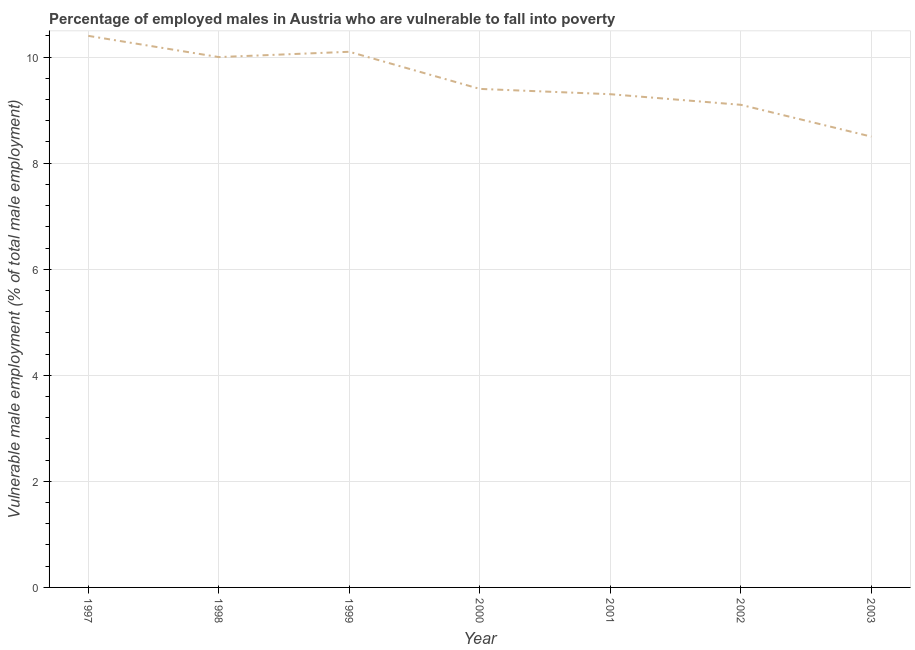What is the percentage of employed males who are vulnerable to fall into poverty in 2002?
Offer a terse response. 9.1. Across all years, what is the maximum percentage of employed males who are vulnerable to fall into poverty?
Ensure brevity in your answer.  10.4. In which year was the percentage of employed males who are vulnerable to fall into poverty minimum?
Give a very brief answer. 2003. What is the sum of the percentage of employed males who are vulnerable to fall into poverty?
Your response must be concise. 66.8. What is the difference between the percentage of employed males who are vulnerable to fall into poverty in 1997 and 2001?
Offer a terse response. 1.1. What is the average percentage of employed males who are vulnerable to fall into poverty per year?
Offer a terse response. 9.54. What is the median percentage of employed males who are vulnerable to fall into poverty?
Provide a succinct answer. 9.4. In how many years, is the percentage of employed males who are vulnerable to fall into poverty greater than 6.4 %?
Offer a terse response. 7. What is the ratio of the percentage of employed males who are vulnerable to fall into poverty in 1998 to that in 2000?
Your answer should be very brief. 1.06. Is the percentage of employed males who are vulnerable to fall into poverty in 1998 less than that in 1999?
Give a very brief answer. Yes. What is the difference between the highest and the second highest percentage of employed males who are vulnerable to fall into poverty?
Your answer should be very brief. 0.3. What is the difference between the highest and the lowest percentage of employed males who are vulnerable to fall into poverty?
Offer a terse response. 1.9. In how many years, is the percentage of employed males who are vulnerable to fall into poverty greater than the average percentage of employed males who are vulnerable to fall into poverty taken over all years?
Your answer should be compact. 3. Does the percentage of employed males who are vulnerable to fall into poverty monotonically increase over the years?
Your answer should be compact. No. Are the values on the major ticks of Y-axis written in scientific E-notation?
Keep it short and to the point. No. Does the graph contain grids?
Your answer should be compact. Yes. What is the title of the graph?
Provide a succinct answer. Percentage of employed males in Austria who are vulnerable to fall into poverty. What is the label or title of the Y-axis?
Provide a succinct answer. Vulnerable male employment (% of total male employment). What is the Vulnerable male employment (% of total male employment) in 1997?
Offer a terse response. 10.4. What is the Vulnerable male employment (% of total male employment) of 1999?
Your response must be concise. 10.1. What is the Vulnerable male employment (% of total male employment) of 2000?
Keep it short and to the point. 9.4. What is the Vulnerable male employment (% of total male employment) of 2001?
Your answer should be compact. 9.3. What is the Vulnerable male employment (% of total male employment) in 2002?
Your response must be concise. 9.1. What is the difference between the Vulnerable male employment (% of total male employment) in 1997 and 1999?
Ensure brevity in your answer.  0.3. What is the difference between the Vulnerable male employment (% of total male employment) in 1998 and 1999?
Provide a short and direct response. -0.1. What is the difference between the Vulnerable male employment (% of total male employment) in 1998 and 2000?
Your answer should be very brief. 0.6. What is the difference between the Vulnerable male employment (% of total male employment) in 1998 and 2002?
Offer a very short reply. 0.9. What is the difference between the Vulnerable male employment (% of total male employment) in 1999 and 2001?
Offer a terse response. 0.8. What is the difference between the Vulnerable male employment (% of total male employment) in 2000 and 2002?
Offer a terse response. 0.3. What is the ratio of the Vulnerable male employment (% of total male employment) in 1997 to that in 1998?
Provide a short and direct response. 1.04. What is the ratio of the Vulnerable male employment (% of total male employment) in 1997 to that in 2000?
Offer a terse response. 1.11. What is the ratio of the Vulnerable male employment (% of total male employment) in 1997 to that in 2001?
Provide a short and direct response. 1.12. What is the ratio of the Vulnerable male employment (% of total male employment) in 1997 to that in 2002?
Your answer should be very brief. 1.14. What is the ratio of the Vulnerable male employment (% of total male employment) in 1997 to that in 2003?
Your response must be concise. 1.22. What is the ratio of the Vulnerable male employment (% of total male employment) in 1998 to that in 2000?
Offer a very short reply. 1.06. What is the ratio of the Vulnerable male employment (% of total male employment) in 1998 to that in 2001?
Your answer should be very brief. 1.07. What is the ratio of the Vulnerable male employment (% of total male employment) in 1998 to that in 2002?
Make the answer very short. 1.1. What is the ratio of the Vulnerable male employment (% of total male employment) in 1998 to that in 2003?
Provide a succinct answer. 1.18. What is the ratio of the Vulnerable male employment (% of total male employment) in 1999 to that in 2000?
Provide a short and direct response. 1.07. What is the ratio of the Vulnerable male employment (% of total male employment) in 1999 to that in 2001?
Provide a succinct answer. 1.09. What is the ratio of the Vulnerable male employment (% of total male employment) in 1999 to that in 2002?
Provide a short and direct response. 1.11. What is the ratio of the Vulnerable male employment (% of total male employment) in 1999 to that in 2003?
Keep it short and to the point. 1.19. What is the ratio of the Vulnerable male employment (% of total male employment) in 2000 to that in 2001?
Offer a terse response. 1.01. What is the ratio of the Vulnerable male employment (% of total male employment) in 2000 to that in 2002?
Your answer should be very brief. 1.03. What is the ratio of the Vulnerable male employment (% of total male employment) in 2000 to that in 2003?
Offer a very short reply. 1.11. What is the ratio of the Vulnerable male employment (% of total male employment) in 2001 to that in 2002?
Your answer should be compact. 1.02. What is the ratio of the Vulnerable male employment (% of total male employment) in 2001 to that in 2003?
Provide a succinct answer. 1.09. What is the ratio of the Vulnerable male employment (% of total male employment) in 2002 to that in 2003?
Your response must be concise. 1.07. 